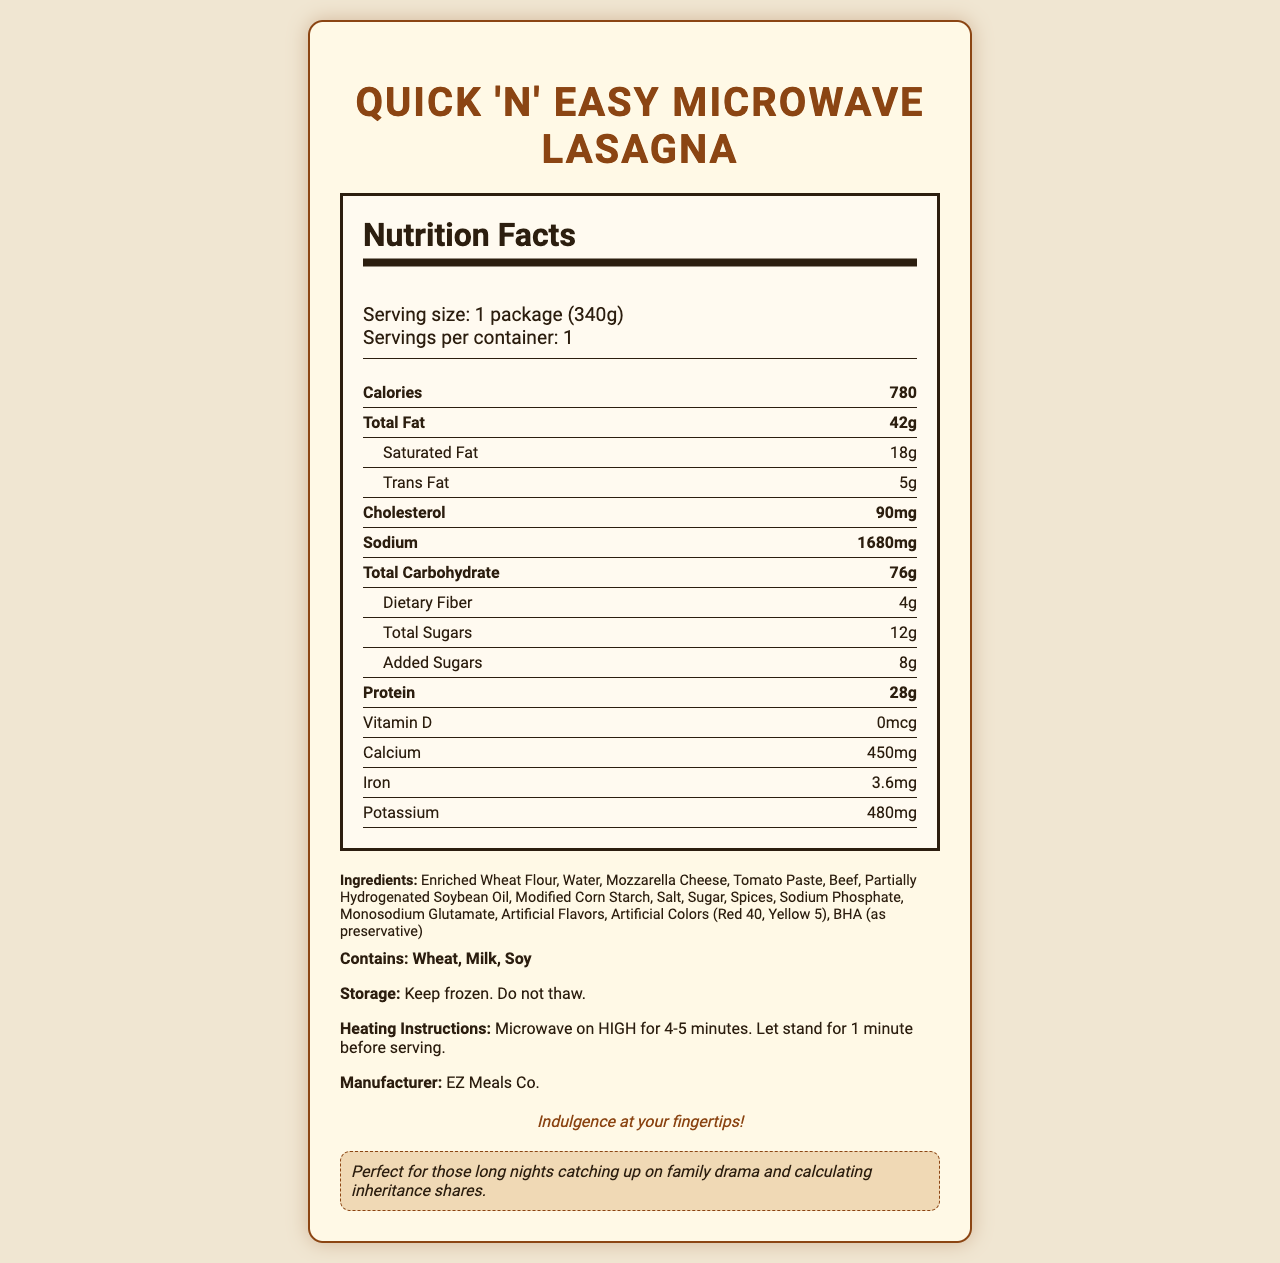what is the serving size? The serving size is listed as "1 package (340g)" in the document.
Answer: 1 package (340g) how many calories are in one serving? The calories per serving are listed as 780 in the document.
Answer: 780 what is the total fat content in grams? The total fat content is mentioned as 42 grams in the document.
Answer: 42g how much trans fat is in one serving? The document states that there are 5 grams of trans fat in one serving.
Answer: 5g does this food contain any dietary fiber? The document states that the total dietary fiber content is 4 grams.
Answer: Yes which ingredient is used as a preservative? The last ingredient listed is BHA, which is used as a preservative.
Answer: BHA what is the sodium content in one serving? The sodium content in one serving is listed as 1680 milligrams.
Answer: 1680mg what are the allergens present in this product? The allergens listed are Wheat, Milk, and Soy.
Answer: Wheat, Milk, Soy what should you do before serving after microwaving? The heating instructions state to let the product stand for 1 minute before serving after microwaving.
Answer: Let stand for 1 minute is vitamin d present in this product? The Vitamin D content is listed as 0, indicating it is not present in the product.
Answer: No what is the main idea of this document? The document contains detailed nutritional facts about "Quick 'n' Easy Microwave Lasagna," ingredients, allergens, storage instructions, heating method, and manufacturer's details.
Answer: The main idea of the document is to provide nutritional information for "Quick 'n' Easy Microwave Lasagna," including its ingredients, allergens, and heating instructions. what is the calcium content in milligrams? A. 350 B. 400 C. 450 D. 500 The document lists the calcium content as 450 milligrams, making option C the correct answer.
Answer: C. 450 how many grams of saturated fat are in the product? A. 12 B. 16 C. 18 D. 20 According to the document, the product contains 18 grams of saturated fat, making C the correct choice.
Answer: C. 18 does this product contain any artificial colors? The document lists "Artificial Colors (Red 40, Yellow 5)" as part of the ingredients.
Answer: Yes how many grams of added sugars does the product contain? The nutritional facts in the document state that there are 8 grams of added sugars.
Answer: 8g which company manufactures this product? The manufacturer is listed as "EZ Meals Co." in the document.
Answer: EZ Meals Co. are the ingredient proportions or quantities provided? The document lists the ingredients but does not provide the specific proportions or quantities of each ingredient.
Answer: Cannot be determined 